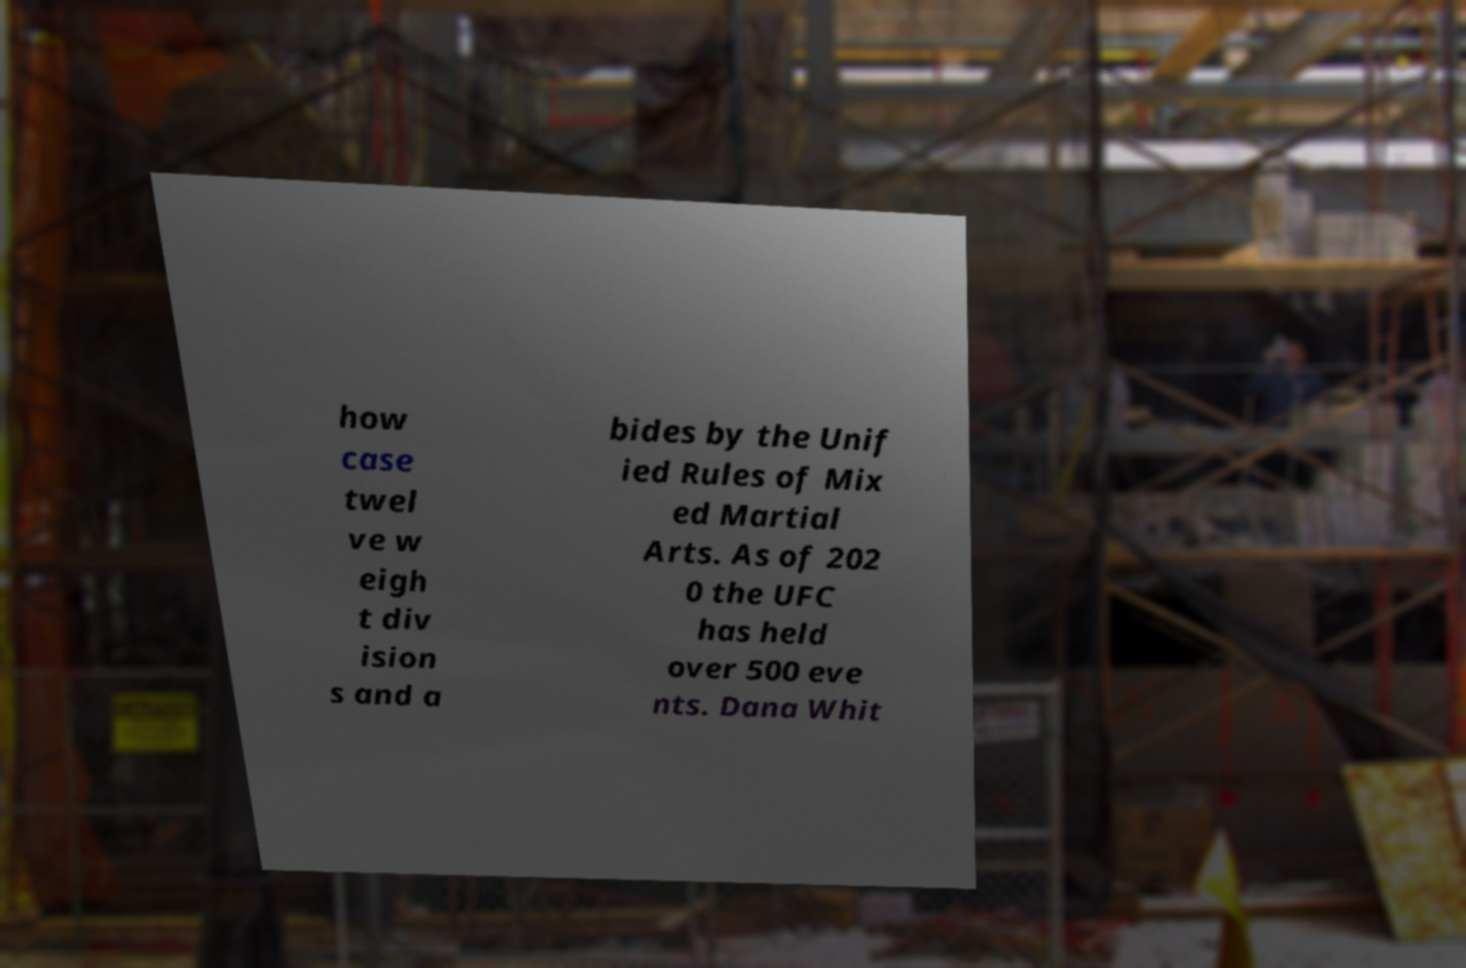Could you extract and type out the text from this image? how case twel ve w eigh t div ision s and a bides by the Unif ied Rules of Mix ed Martial Arts. As of 202 0 the UFC has held over 500 eve nts. Dana Whit 